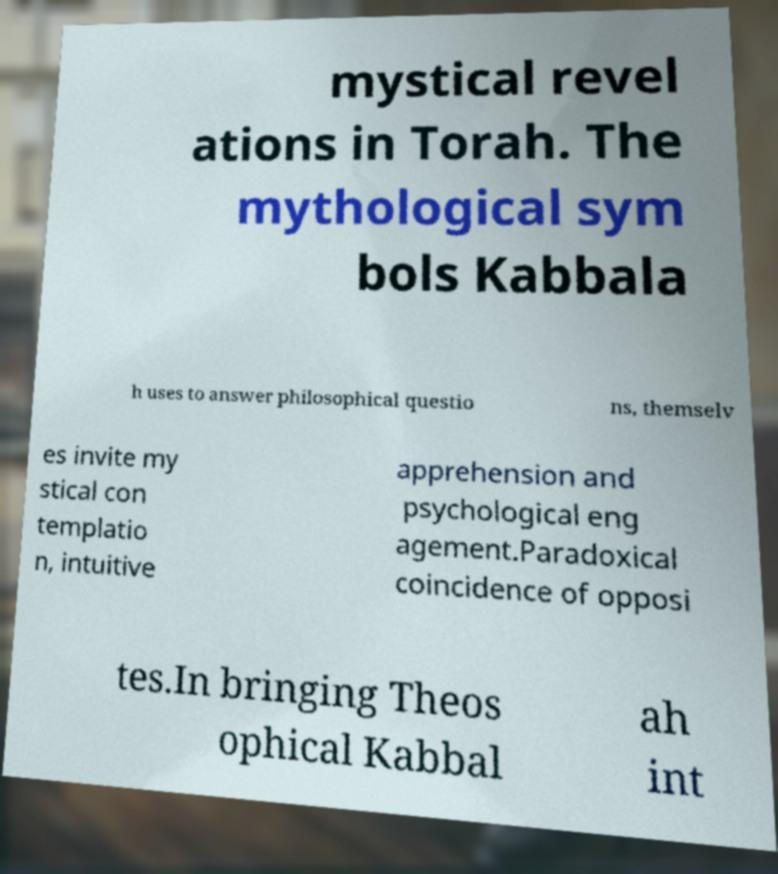I need the written content from this picture converted into text. Can you do that? mystical revel ations in Torah. The mythological sym bols Kabbala h uses to answer philosophical questio ns, themselv es invite my stical con templatio n, intuitive apprehension and psychological eng agement.Paradoxical coincidence of opposi tes.In bringing Theos ophical Kabbal ah int 